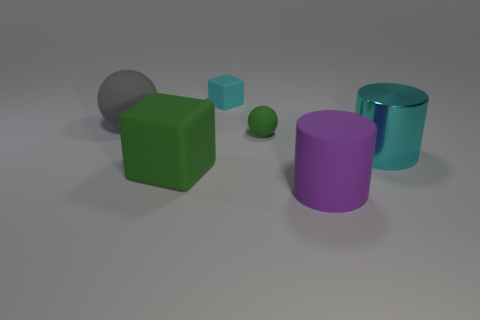Add 4 large purple things. How many objects exist? 10 Subtract all cylinders. How many objects are left? 4 Subtract all metallic cylinders. Subtract all big blue matte cylinders. How many objects are left? 5 Add 3 gray rubber things. How many gray rubber things are left? 4 Add 2 green spheres. How many green spheres exist? 3 Subtract 0 red balls. How many objects are left? 6 